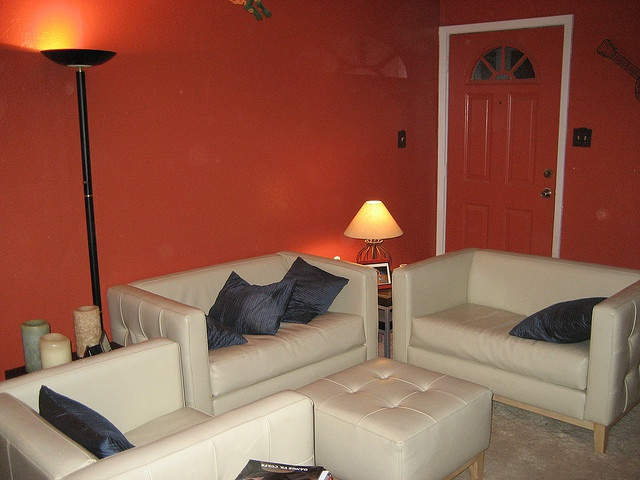Describe the objects in this image and their specific colors. I can see couch in red, gray, and tan tones, chair in red, tan, and beige tones, couch in red, tan, and gray tones, book in red, gray, black, and ivory tones, and vase in red, tan, gray, brown, and black tones in this image. 